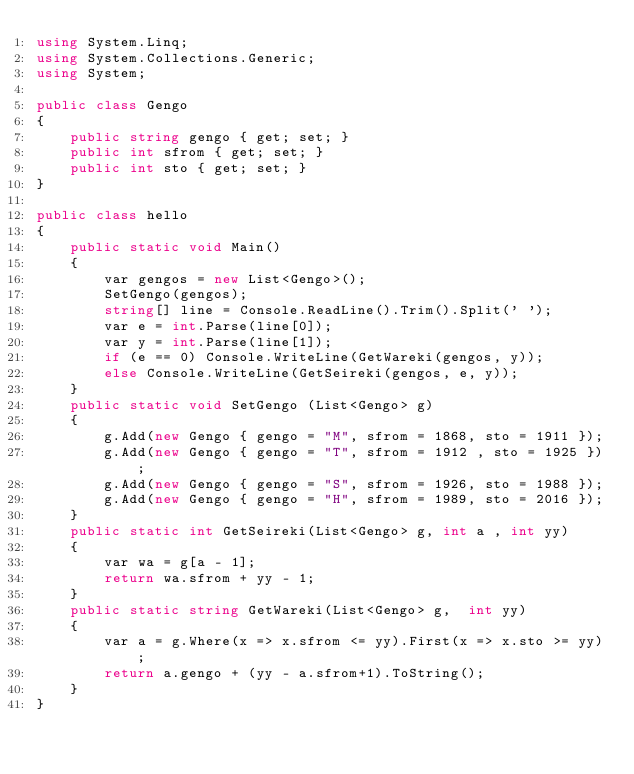<code> <loc_0><loc_0><loc_500><loc_500><_C#_>using System.Linq;
using System.Collections.Generic;
using System;

public class Gengo
{
    public string gengo { get; set; }
    public int sfrom { get; set; }
    public int sto { get; set; }
}

public class hello
{
    public static void Main()
    {
        var gengos = new List<Gengo>();
        SetGengo(gengos);
        string[] line = Console.ReadLine().Trim().Split(' ');
        var e = int.Parse(line[0]);
        var y = int.Parse(line[1]);
        if (e == 0) Console.WriteLine(GetWareki(gengos, y));
        else Console.WriteLine(GetSeireki(gengos, e, y));
    }
    public static void SetGengo (List<Gengo> g)
    {
        g.Add(new Gengo { gengo = "M", sfrom = 1868, sto = 1911 });
        g.Add(new Gengo { gengo = "T", sfrom = 1912 , sto = 1925 });
        g.Add(new Gengo { gengo = "S", sfrom = 1926, sto = 1988 });
        g.Add(new Gengo { gengo = "H", sfrom = 1989, sto = 2016 });
    }
    public static int GetSeireki(List<Gengo> g, int a , int yy)
    {
        var wa = g[a - 1];
        return wa.sfrom + yy - 1;
    }
    public static string GetWareki(List<Gengo> g,  int yy)
    {
        var a = g.Where(x => x.sfrom <= yy).First(x => x.sto >= yy);
        return a.gengo + (yy - a.sfrom+1).ToString();
    }
}</code> 